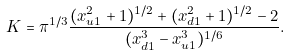<formula> <loc_0><loc_0><loc_500><loc_500>K = \pi ^ { 1 / 3 } \frac { ( x _ { u 1 } ^ { 2 } + 1 ) ^ { 1 / 2 } + ( x _ { d 1 } ^ { 2 } + 1 ) ^ { 1 / 2 } - 2 } { ( x _ { d 1 } ^ { 3 } - x _ { u 1 } ^ { 3 } ) ^ { 1 / 6 } } .</formula> 